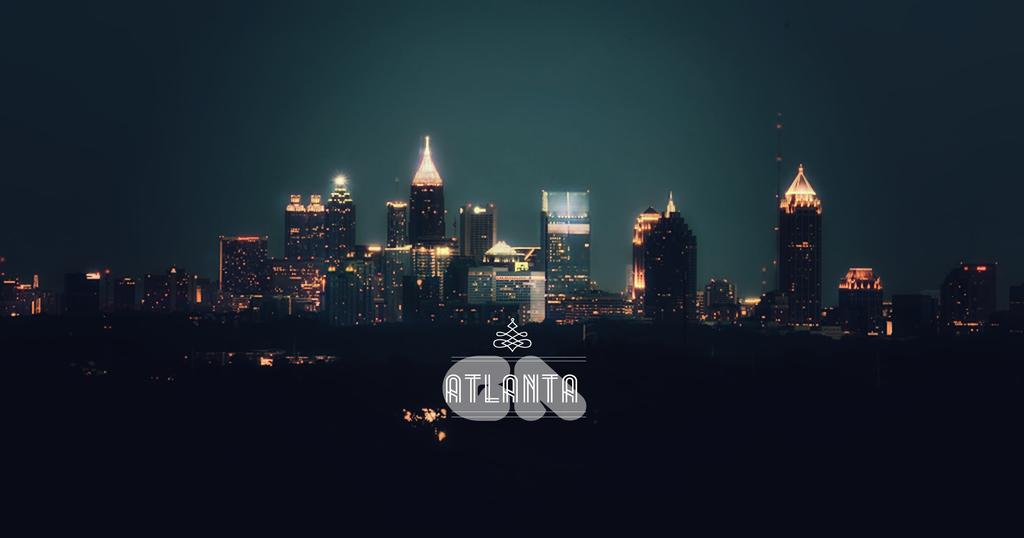What city is this?
Give a very brief answer. Atlanta. 